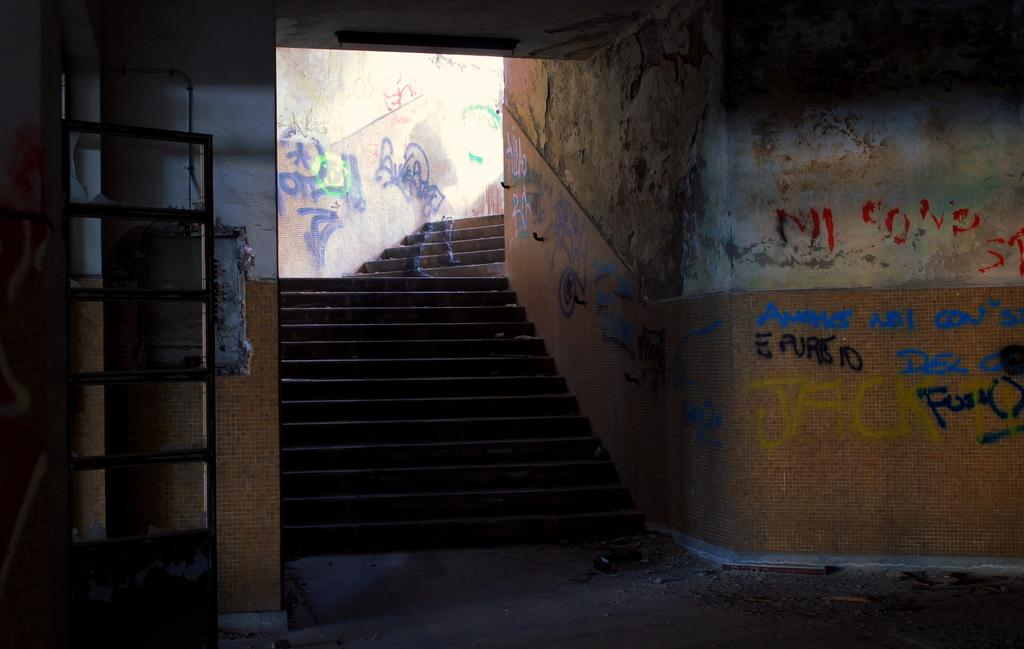What type of structure can be seen in the image? There are walls in the image, suggesting a structure of some kind. Is there any entrance or exit visible in the image? Yes, there is a door in the image. Are there any architectural features present in the image? Yes, there are steps in the image. What is the artistic element present on the walls in the image? There is graffiti art on the walls in the image. Can you describe the illusion of a person in the image? The image appears to depict an illusion of a person, possibly created through the graffiti art or other artistic techniques. How many pizzas are being held by the person in the image? There is no person holding pizzas in the image; it features an illusion of a person created through graffiti art. What type of writing instrument is being used by the person in the image? There is no person using a quill or any other writing instrument in the image; it features an illusion of a person created through graffiti art. 